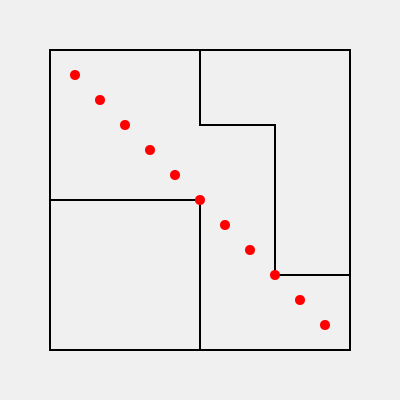In this mysterious library layout, enigmatic footprints traverse the maze-like corridors. If each footprint represents a step of 25 units, and the pattern continues in the same direction, how many more steps will it take to reach the exit at the bottom right corner? To solve this pattern recognition task, let's follow these steps:

1. Observe the pattern: The footprints (red dots) form a diagonal line from top-left to bottom-right.

2. Calculate the distance between footprints:
   Each step is 25 units in both x and y directions, forming a 45-degree angle.

3. Count the existing footprints:
   There are 11 visible footprints.

4. Determine the current position:
   The last visible footprint is at coordinates (325, 325).

5. Calculate the distance to the exit:
   The exit is at (350, 350).
   Distance remaining: $\sqrt{(350-325)^2 + (350-325)^2} = \sqrt{2 \cdot 25^2} = 25\sqrt{2}$ units

6. Calculate the number of steps needed:
   Since each step is 25 units long, and the remaining distance is $25\sqrt{2}$, we need:
   $\frac{25\sqrt{2}}{25} = \sqrt{2}$ steps

7. Round up to the nearest whole step:
   $\sqrt{2} \approx 1.414$, which rounds up to 2 steps.
Answer: 2 steps 